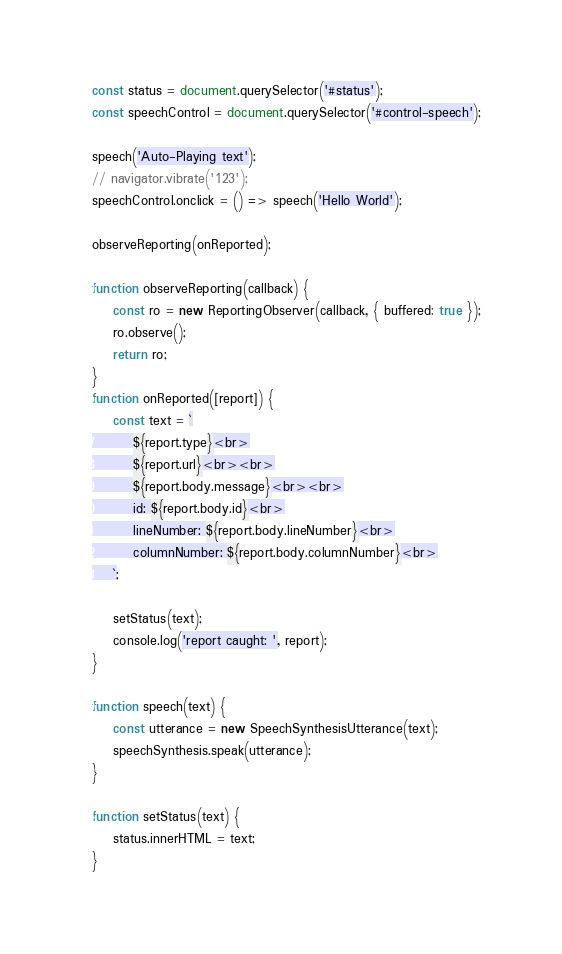<code> <loc_0><loc_0><loc_500><loc_500><_JavaScript_>const status = document.querySelector('#status');
const speechControl = document.querySelector('#control-speech');

speech('Auto-Playing text');
// navigator.vibrate('123');
speechControl.onclick = () => speech('Hello World');

observeReporting(onReported);

function observeReporting(callback) {
    const ro = new ReportingObserver(callback, { buffered: true });
    ro.observe();
    return ro;
}
function onReported([report]) {
    const text = `
        ${report.type}<br>
        ${report.url}<br><br>
        ${report.body.message}<br><br>
        id: ${report.body.id}<br>
        lineNumber: ${report.body.lineNumber}<br>
        columnNumber: ${report.body.columnNumber}<br>
    `;

    setStatus(text);
    console.log('report caught: ', report);
}

function speech(text) {
    const utterance = new SpeechSynthesisUtterance(text);
    speechSynthesis.speak(utterance);
}

function setStatus(text) {
    status.innerHTML = text;
}</code> 